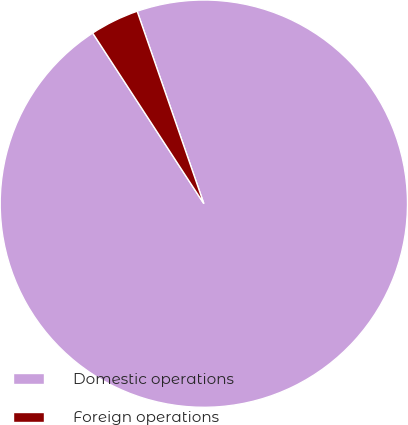Convert chart to OTSL. <chart><loc_0><loc_0><loc_500><loc_500><pie_chart><fcel>Domestic operations<fcel>Foreign operations<nl><fcel>96.12%<fcel>3.88%<nl></chart> 